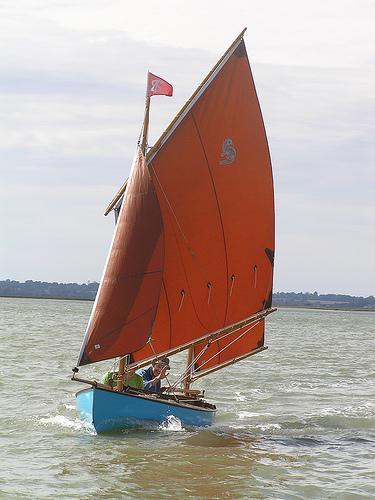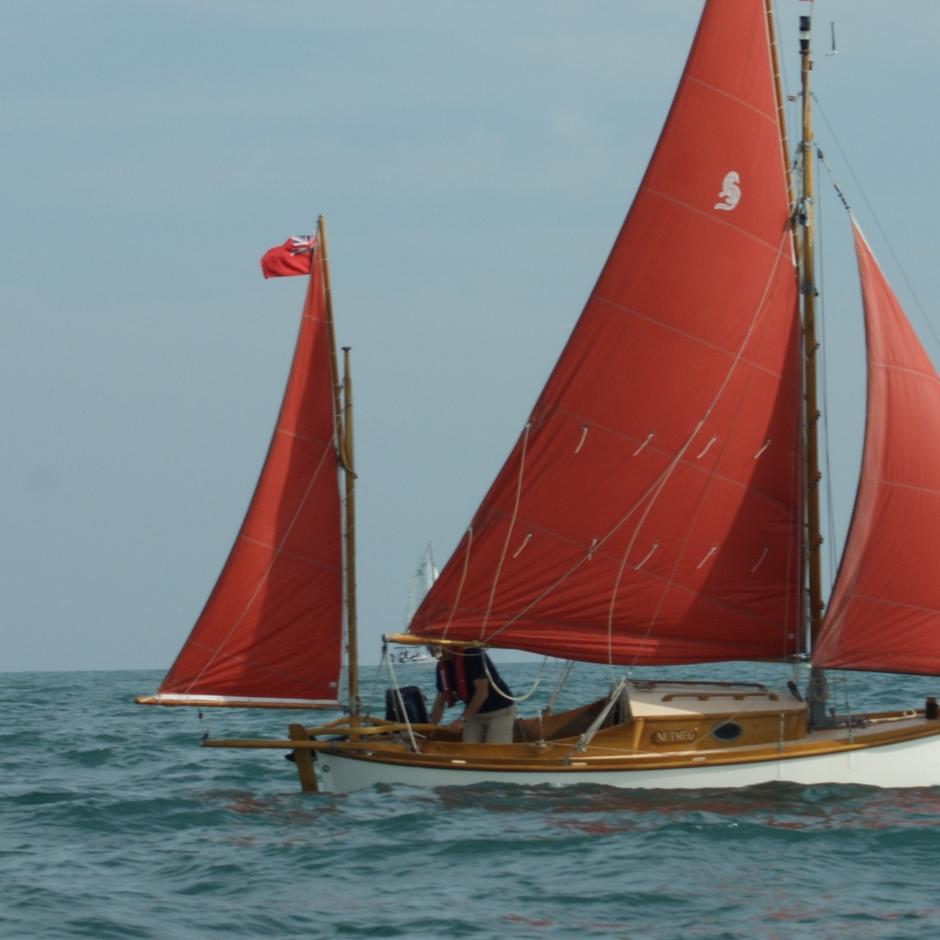The first image is the image on the left, the second image is the image on the right. Assess this claim about the two images: "The body of the boat in the image on the right is white.". Correct or not? Answer yes or no. Yes. 